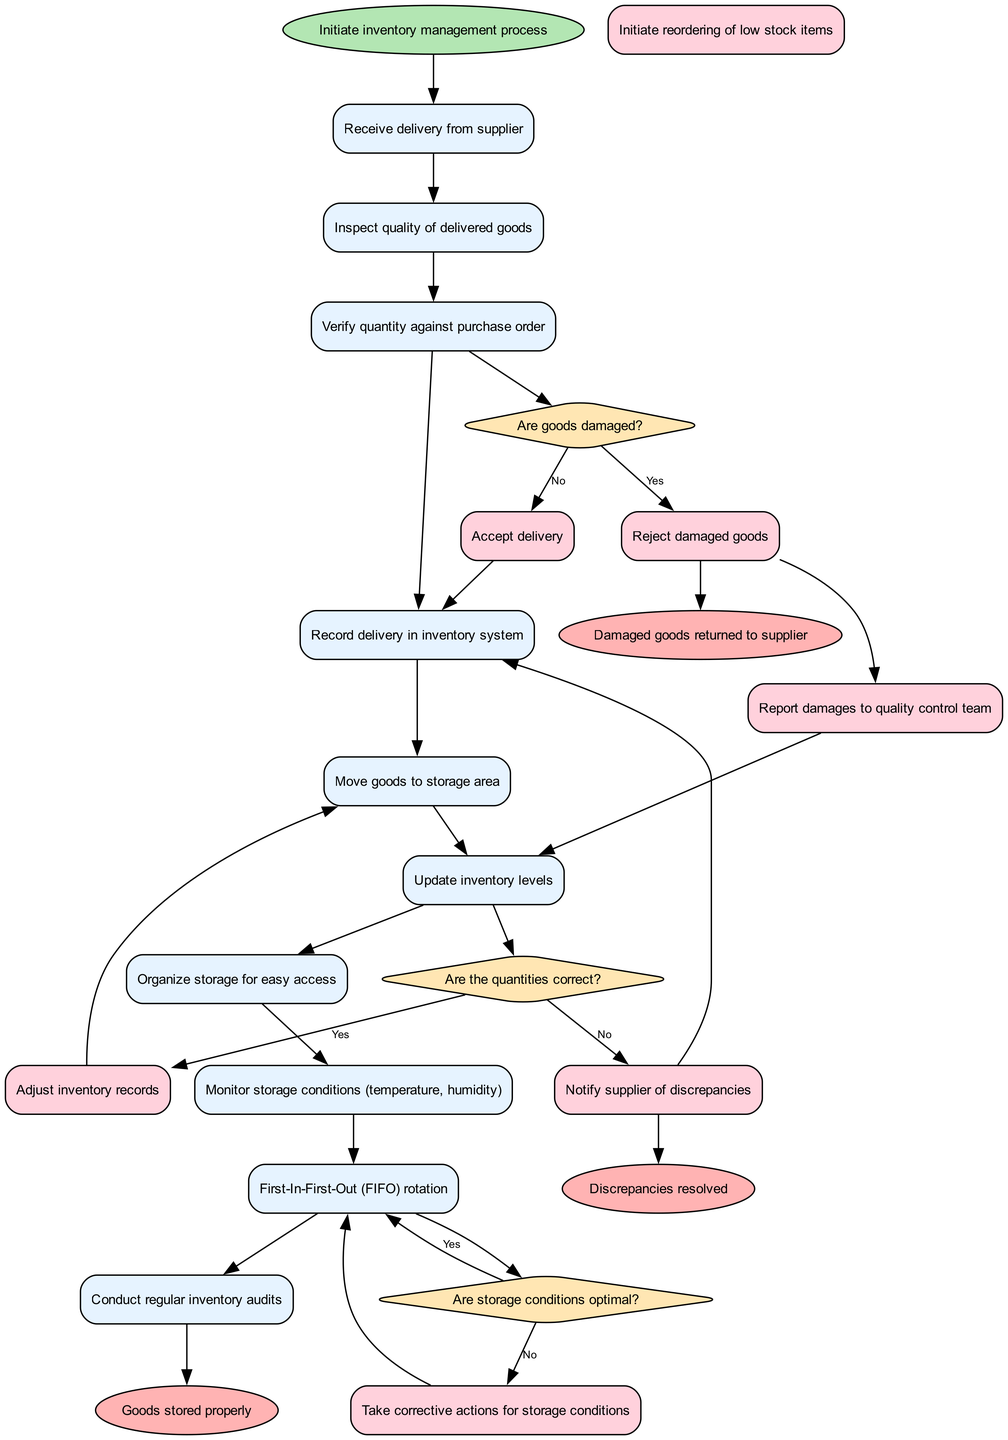What is the starting event in this diagram? The starting event is labeled as "Initiate inventory management process". This is the first node in the flow and serves as the point from which the entire process begins.
Answer: Initiate inventory management process How many activities are represented in the diagram? The diagram contains ten activities in total, each listed sequentially and connected in the flow. This count includes all the nodes designated as activities.
Answer: 10 What decision point follows the inspection of goods? The decision point that follows the inspection of goods is about whether "Are goods damaged?". This decision comes directly after the activity of inspecting the quality of delivered goods.
Answer: Are goods damaged? Which action is taken if the quantities are not correct? If the quantities are not correct, the action taken is to "Notify supplier of discrepancies". This action follows the decision point directly related to verifying the quantity against the purchase order.
Answer: Notify supplier of discrepancies What happens to damaged goods according to the end events? Damaged goods are returned to the supplier, as indicated by the corresponding end event labeled "Damaged goods returned to supplier". This directly concludes the process regarding damaged items.
Answer: Damaged goods returned to supplier How many end events are there in the diagram? There are three end events listed in the diagram, each representing a different conclusion to the flow of activities related to inventory management.
Answer: 3 What specific action initiates the reordering process? The action that initiates the reordering process is "Initiate reordering of low stock items". This action is triggered when the quantities of items are deemed to be incorrect after verification.
Answer: Initiate reordering of low stock items What action is associated with optimal storage conditions? The action associated with optimal storage conditions is "Take corrective actions for storage conditions". This action follows the decision point that checks whether storage conditions are optimal.
Answer: Take corrective actions for storage conditions What is the connection between damaged goods and quality control? The connection is that if goods are damaged, there is a specific action to "Report damages to quality control team". This step ensures that quality control is informed of any issues with delivered goods.
Answer: Report damages to quality control team 